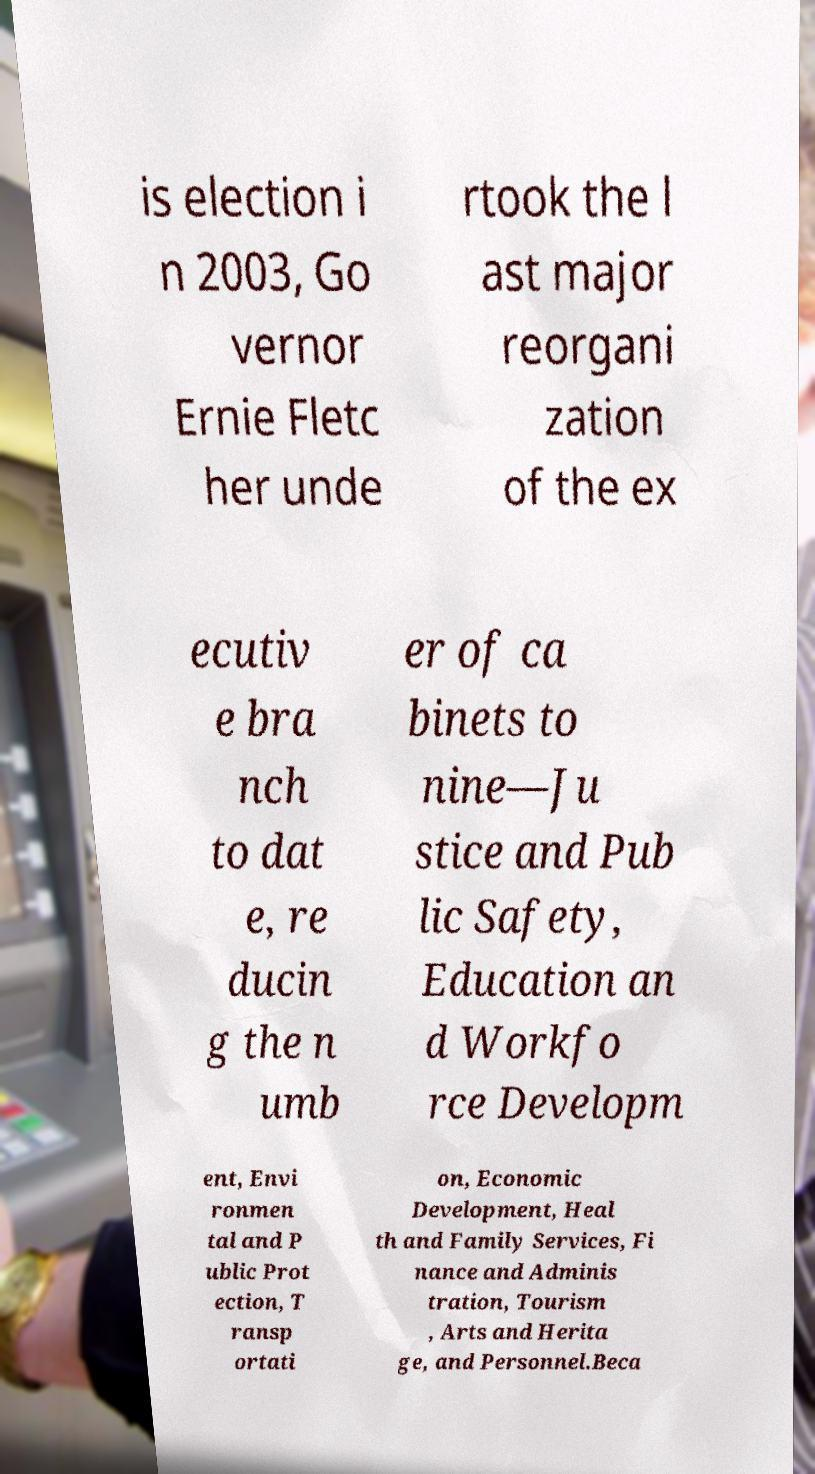What messages or text are displayed in this image? I need them in a readable, typed format. is election i n 2003, Go vernor Ernie Fletc her unde rtook the l ast major reorgani zation of the ex ecutiv e bra nch to dat e, re ducin g the n umb er of ca binets to nine—Ju stice and Pub lic Safety, Education an d Workfo rce Developm ent, Envi ronmen tal and P ublic Prot ection, T ransp ortati on, Economic Development, Heal th and Family Services, Fi nance and Adminis tration, Tourism , Arts and Herita ge, and Personnel.Beca 